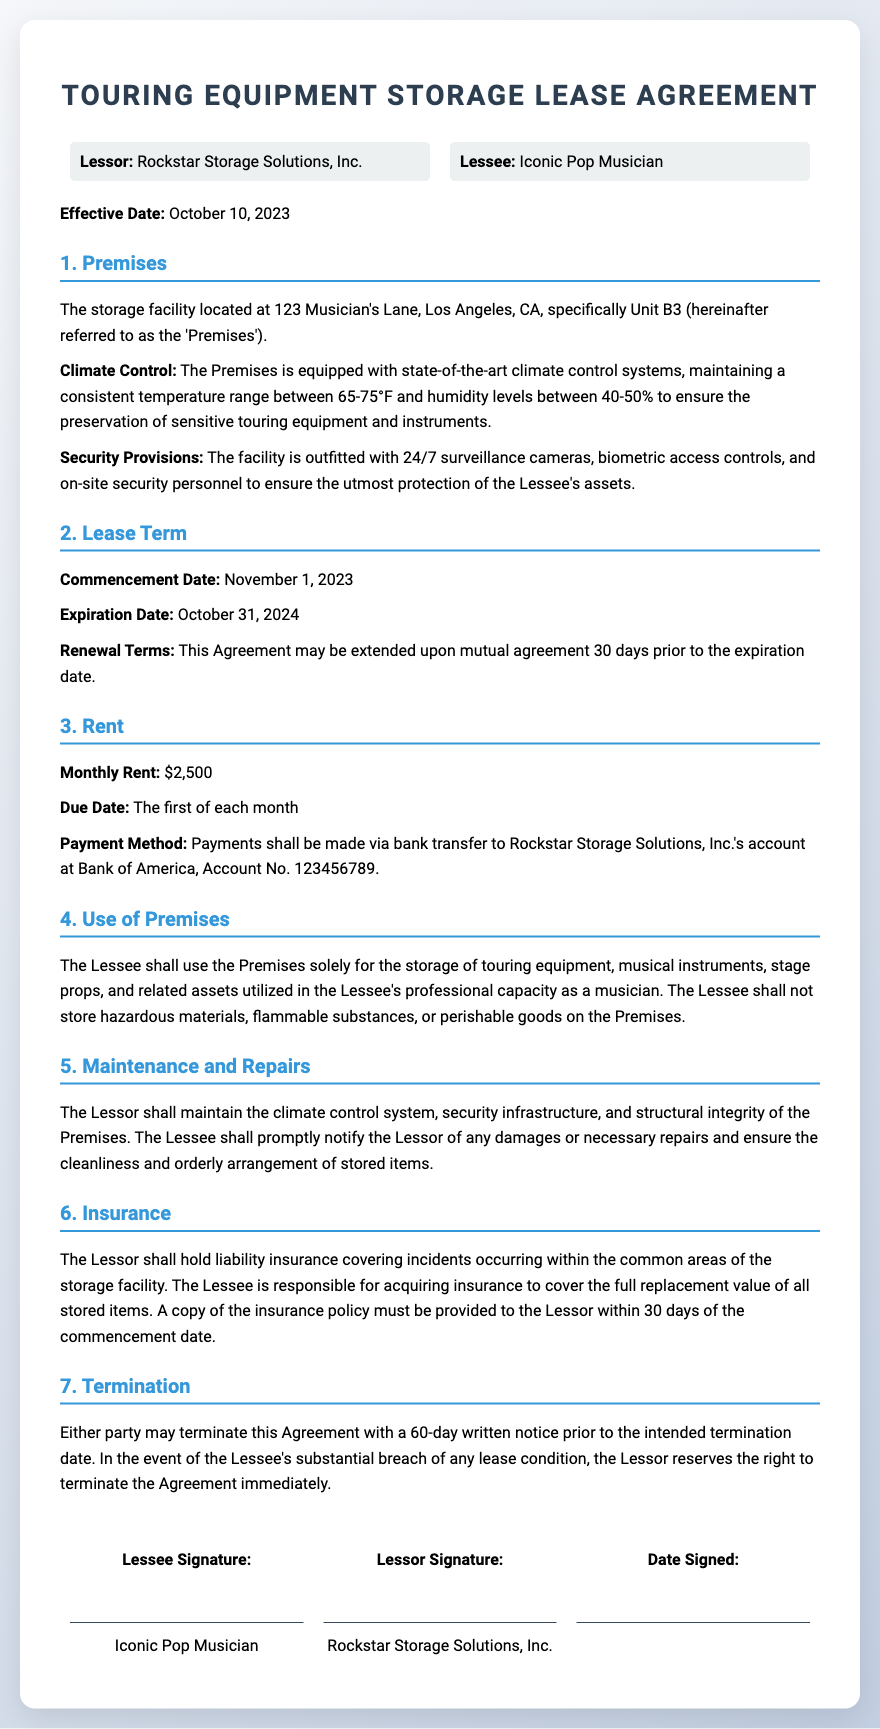What is the name of the Lessor? The Lessor's name is stated in the document as Rockstar Storage Solutions, Inc.
Answer: Rockstar Storage Solutions, Inc What is the effective date of the lease agreement? The effective date is specifically noted in the document as October 10, 2023.
Answer: October 10, 2023 What is the monthly rent for the storage? The document indicates the monthly rent that the Lessee needs to pay is $2,500.
Answer: $2,500 What is the commencement date of the lease? The lease agreement specifies that the commencement date is November 1, 2023.
Answer: November 1, 2023 What is the duration of the lease term? The lease term duration is defined as one year, from the commencement date to the expiration date.
Answer: One year What are the security provisions mentioned? The document lists several security measures including 24/7 surveillance cameras and biometric access controls.
Answer: 24/7 surveillance cameras, biometric access controls What must the Lessee provide within 30 days of the commencement date? The Lessee is required to provide a copy of the insurance policy within the specified time frame.
Answer: A copy of the insurance policy What notice period is required for termination of the lease? The lease stipulates that a 60-day written notice is mandatory for termination by either party.
Answer: 60 days What is prohibited from being stored in the Premises? The Lessee is not allowed to store hazardous materials or perishable goods as stated in the agreement.
Answer: Hazardous materials, perishable goods 